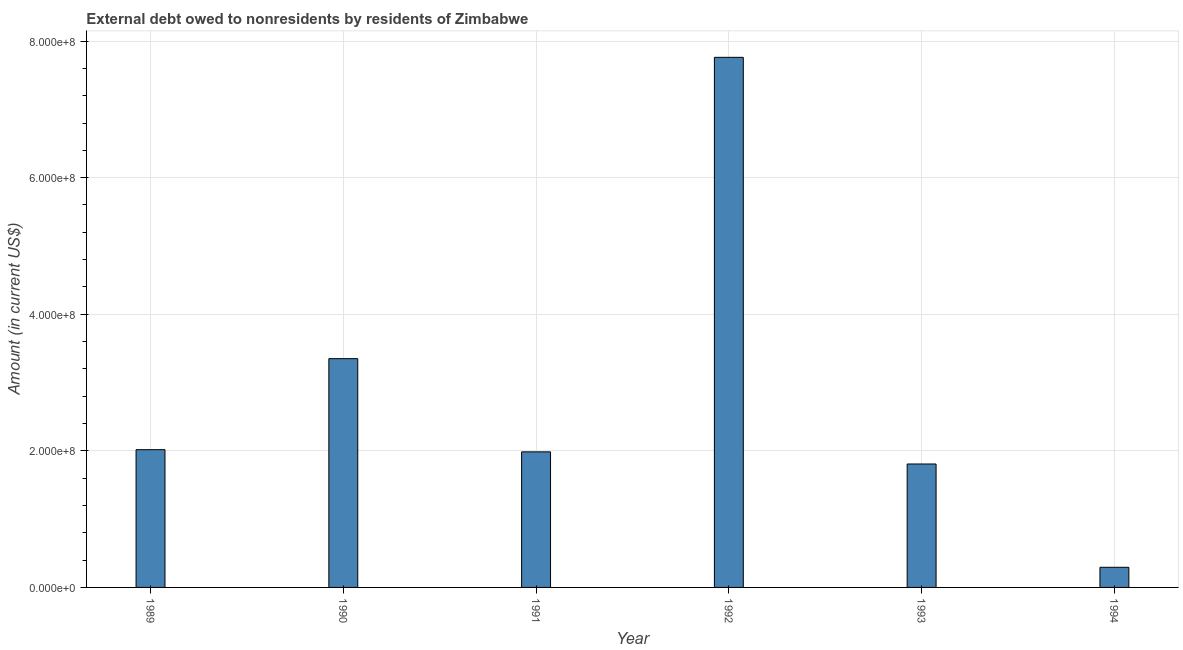What is the title of the graph?
Offer a terse response. External debt owed to nonresidents by residents of Zimbabwe. What is the debt in 1992?
Ensure brevity in your answer.  7.76e+08. Across all years, what is the maximum debt?
Give a very brief answer. 7.76e+08. Across all years, what is the minimum debt?
Offer a very short reply. 2.95e+07. In which year was the debt maximum?
Offer a terse response. 1992. In which year was the debt minimum?
Provide a succinct answer. 1994. What is the sum of the debt?
Offer a very short reply. 1.72e+09. What is the difference between the debt in 1992 and 1994?
Keep it short and to the point. 7.47e+08. What is the average debt per year?
Provide a short and direct response. 2.87e+08. What is the median debt?
Ensure brevity in your answer.  2.00e+08. In how many years, is the debt greater than 680000000 US$?
Provide a short and direct response. 1. What is the ratio of the debt in 1990 to that in 1993?
Offer a terse response. 1.85. Is the difference between the debt in 1989 and 1991 greater than the difference between any two years?
Give a very brief answer. No. What is the difference between the highest and the second highest debt?
Make the answer very short. 4.41e+08. What is the difference between the highest and the lowest debt?
Your answer should be very brief. 7.47e+08. How many bars are there?
Give a very brief answer. 6. Are the values on the major ticks of Y-axis written in scientific E-notation?
Offer a very short reply. Yes. What is the Amount (in current US$) of 1989?
Your answer should be very brief. 2.02e+08. What is the Amount (in current US$) of 1990?
Offer a terse response. 3.35e+08. What is the Amount (in current US$) in 1991?
Give a very brief answer. 1.99e+08. What is the Amount (in current US$) in 1992?
Your response must be concise. 7.76e+08. What is the Amount (in current US$) in 1993?
Your answer should be very brief. 1.81e+08. What is the Amount (in current US$) in 1994?
Provide a short and direct response. 2.95e+07. What is the difference between the Amount (in current US$) in 1989 and 1990?
Provide a short and direct response. -1.33e+08. What is the difference between the Amount (in current US$) in 1989 and 1991?
Keep it short and to the point. 3.19e+06. What is the difference between the Amount (in current US$) in 1989 and 1992?
Provide a succinct answer. -5.75e+08. What is the difference between the Amount (in current US$) in 1989 and 1993?
Your answer should be very brief. 2.09e+07. What is the difference between the Amount (in current US$) in 1989 and 1994?
Your answer should be very brief. 1.72e+08. What is the difference between the Amount (in current US$) in 1990 and 1991?
Provide a succinct answer. 1.36e+08. What is the difference between the Amount (in current US$) in 1990 and 1992?
Keep it short and to the point. -4.41e+08. What is the difference between the Amount (in current US$) in 1990 and 1993?
Give a very brief answer. 1.54e+08. What is the difference between the Amount (in current US$) in 1990 and 1994?
Ensure brevity in your answer.  3.06e+08. What is the difference between the Amount (in current US$) in 1991 and 1992?
Provide a succinct answer. -5.78e+08. What is the difference between the Amount (in current US$) in 1991 and 1993?
Make the answer very short. 1.78e+07. What is the difference between the Amount (in current US$) in 1991 and 1994?
Ensure brevity in your answer.  1.69e+08. What is the difference between the Amount (in current US$) in 1992 and 1993?
Make the answer very short. 5.95e+08. What is the difference between the Amount (in current US$) in 1992 and 1994?
Keep it short and to the point. 7.47e+08. What is the difference between the Amount (in current US$) in 1993 and 1994?
Provide a short and direct response. 1.51e+08. What is the ratio of the Amount (in current US$) in 1989 to that in 1990?
Offer a terse response. 0.6. What is the ratio of the Amount (in current US$) in 1989 to that in 1991?
Provide a succinct answer. 1.02. What is the ratio of the Amount (in current US$) in 1989 to that in 1992?
Your answer should be very brief. 0.26. What is the ratio of the Amount (in current US$) in 1989 to that in 1993?
Ensure brevity in your answer.  1.12. What is the ratio of the Amount (in current US$) in 1989 to that in 1994?
Your response must be concise. 6.84. What is the ratio of the Amount (in current US$) in 1990 to that in 1991?
Offer a very short reply. 1.69. What is the ratio of the Amount (in current US$) in 1990 to that in 1992?
Your answer should be very brief. 0.43. What is the ratio of the Amount (in current US$) in 1990 to that in 1993?
Make the answer very short. 1.85. What is the ratio of the Amount (in current US$) in 1990 to that in 1994?
Ensure brevity in your answer.  11.36. What is the ratio of the Amount (in current US$) in 1991 to that in 1992?
Provide a succinct answer. 0.26. What is the ratio of the Amount (in current US$) in 1991 to that in 1993?
Your answer should be compact. 1.1. What is the ratio of the Amount (in current US$) in 1991 to that in 1994?
Ensure brevity in your answer.  6.73. What is the ratio of the Amount (in current US$) in 1992 to that in 1993?
Provide a short and direct response. 4.29. What is the ratio of the Amount (in current US$) in 1992 to that in 1994?
Your answer should be compact. 26.32. What is the ratio of the Amount (in current US$) in 1993 to that in 1994?
Ensure brevity in your answer.  6.13. 